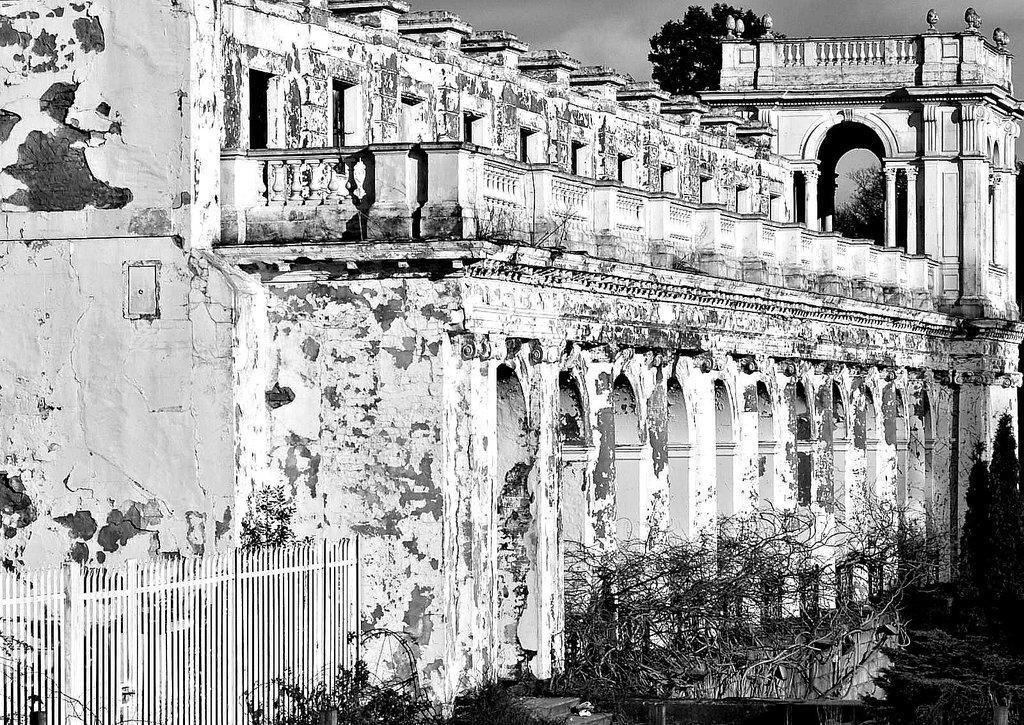Please provide a concise description of this image. In this image there is the sky towards the top of the image, there is a tree towards the top of the image, there is a building, there is a wall towards the left of the image, there is a wooden fence towards the bottom of the image, there are plants towards the bottom of the image, there are plants towards the right of the image. 